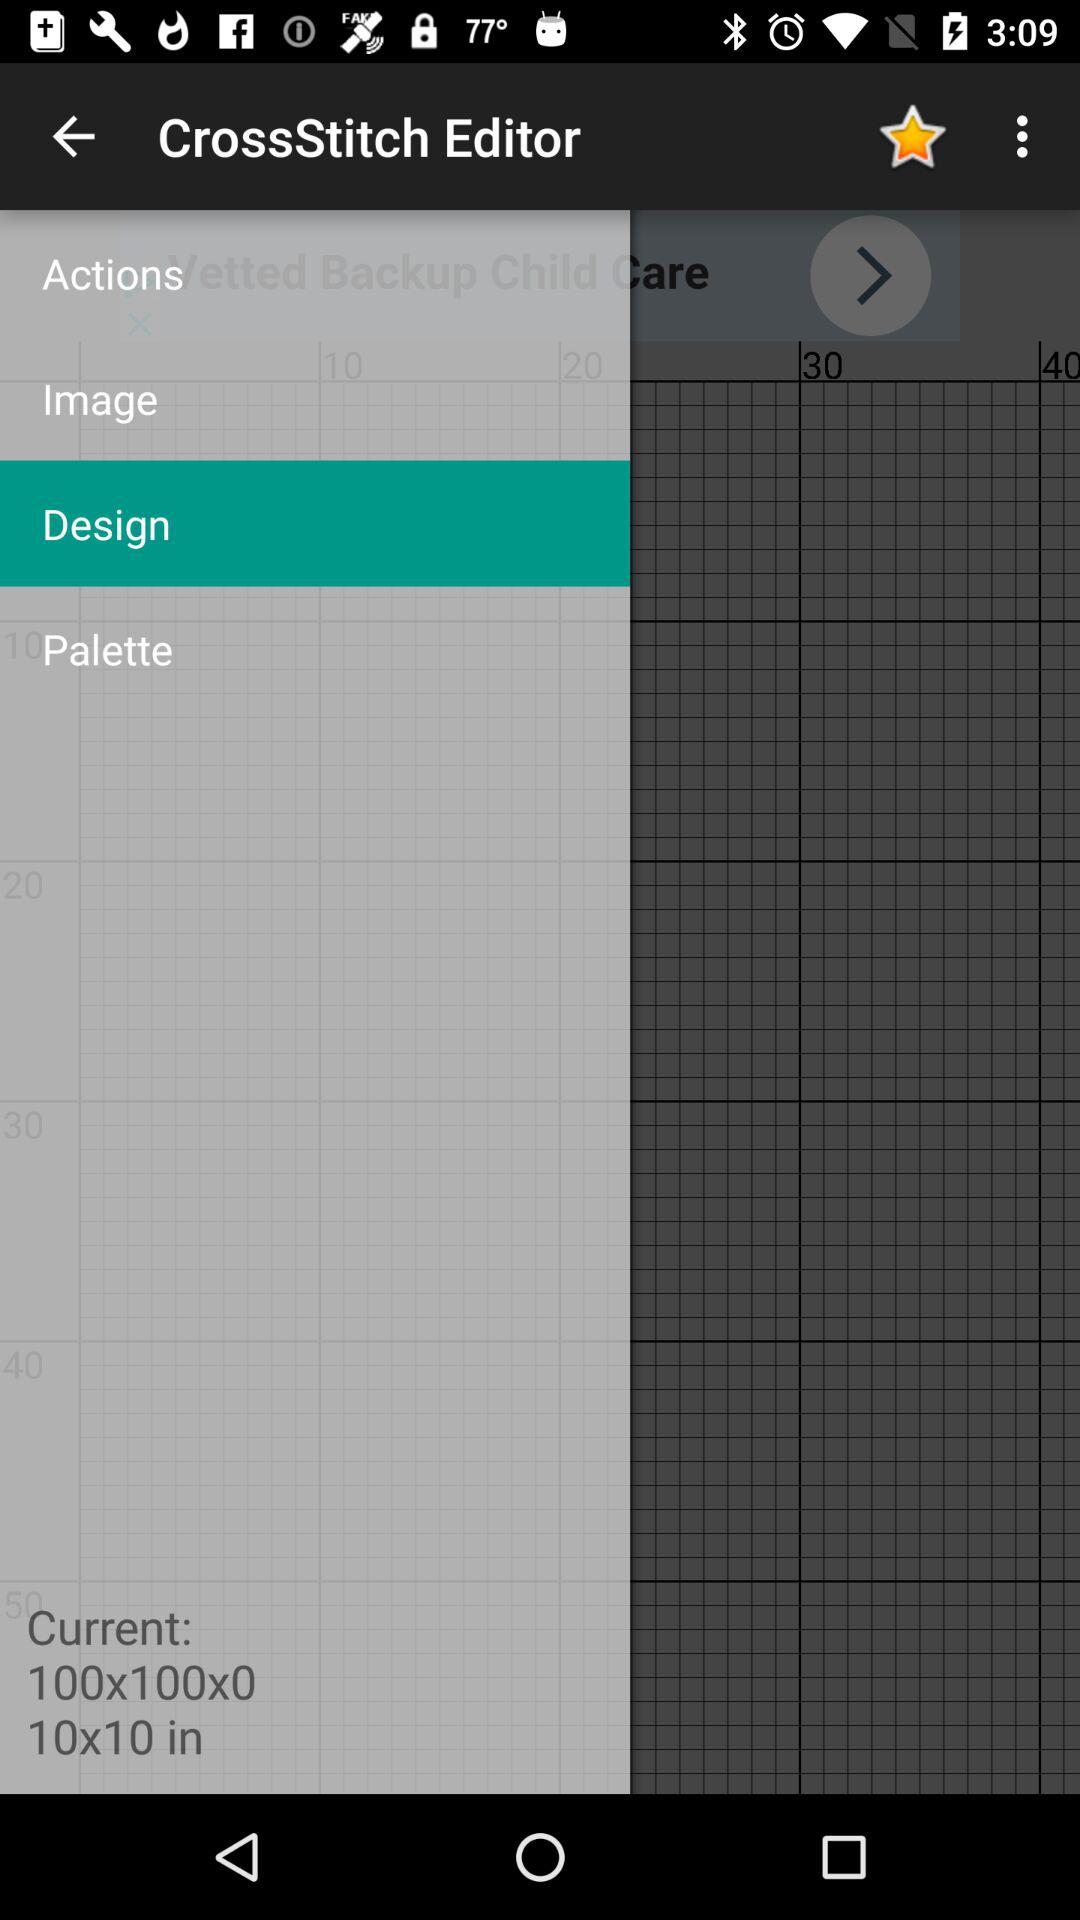How many items are in "Design"?
When the provided information is insufficient, respond with <no answer>. <no answer> 